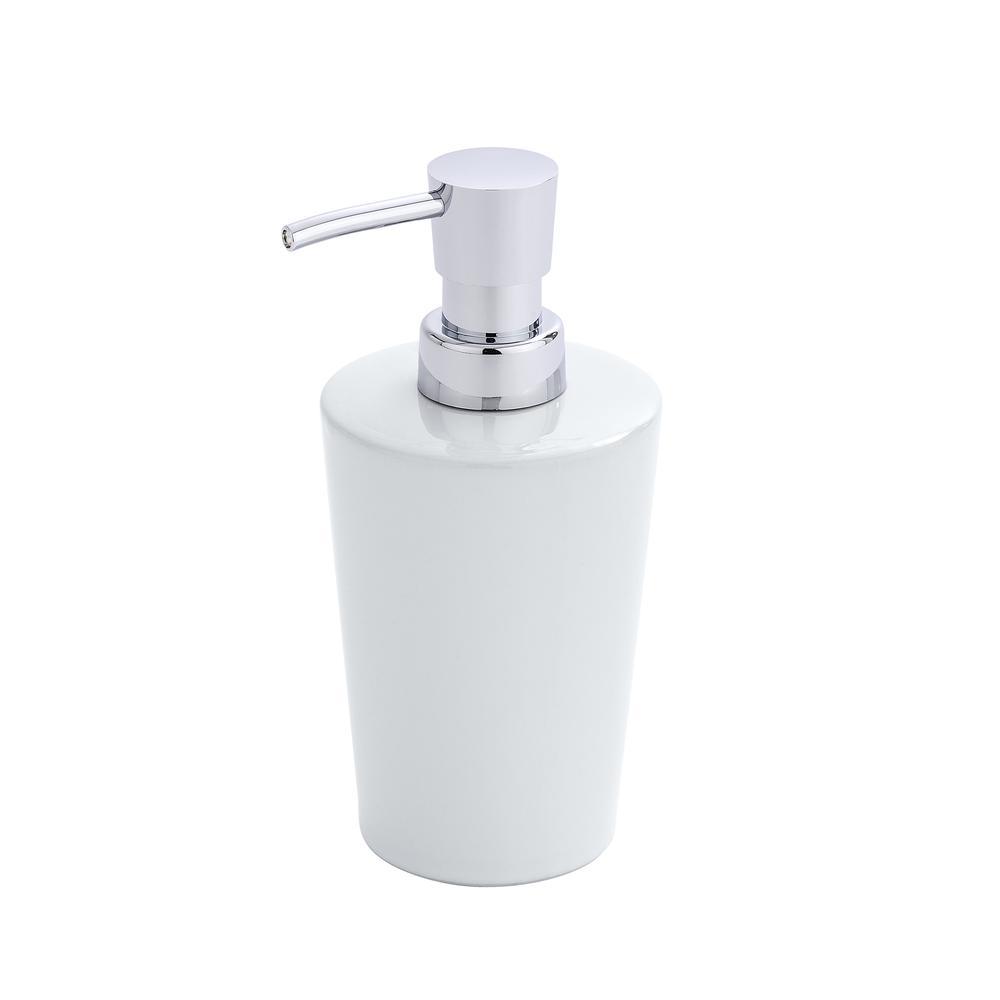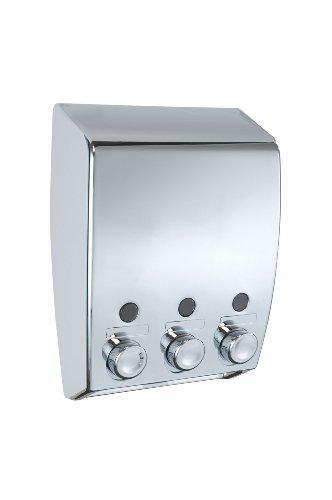The first image is the image on the left, the second image is the image on the right. Evaluate the accuracy of this statement regarding the images: "There is a silver dispenser with three nozzles in the right image.". Is it true? Answer yes or no. Yes. The first image is the image on the left, the second image is the image on the right. For the images shown, is this caption "There is one round soap dispenser with the spout pointing to the left." true? Answer yes or no. Yes. 